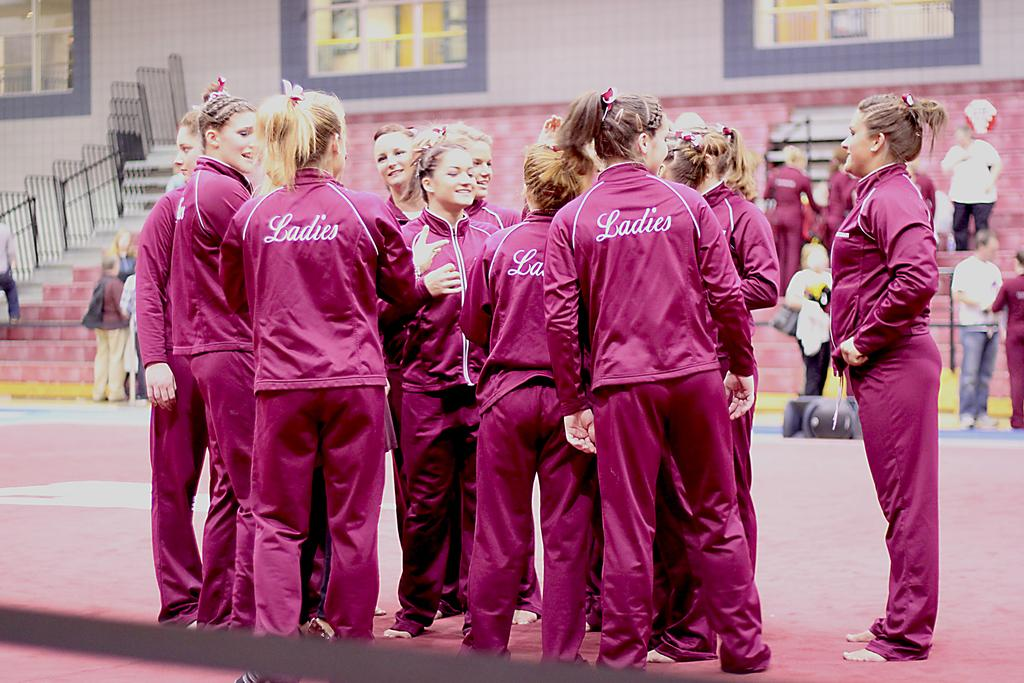Provide a one-sentence caption for the provided image. players huddled toether wearing pink warm ups with ladies on back. 